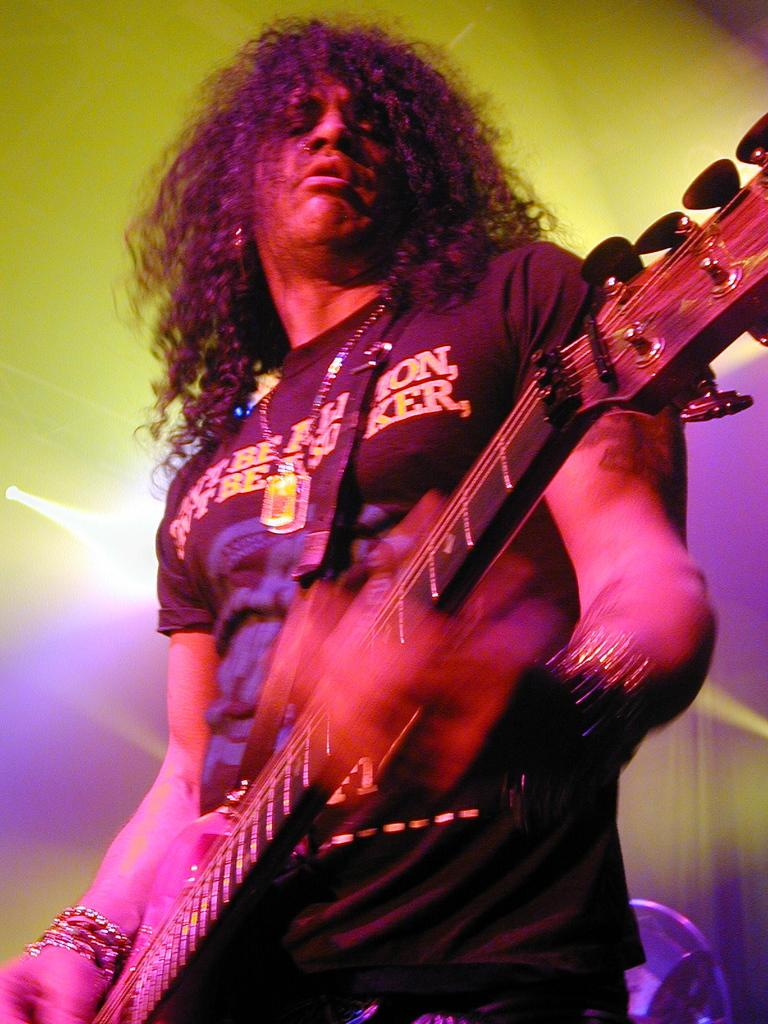What is the man in the image doing? The man is playing guitar in the image. Can you describe the man's hair in the image? The man has small, curly hair. What type of clothing is the man wearing on his upper body? The man is wearing a t-shirt. What type of clothing is the man wearing on his lower body? The man is wearing trousers. What kind of accessory is the man wearing in the image? The man is wearing an ornament. What time does the watch on the man's wrist display in the image? There is no watch visible in the image. What type of canvas is the man painting on in the image? The man is playing guitar, not painting, so there is no canvas present in the image. 